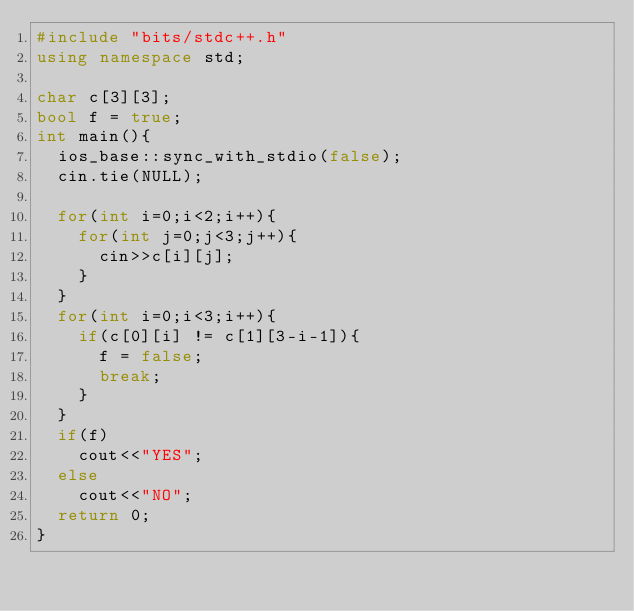Convert code to text. <code><loc_0><loc_0><loc_500><loc_500><_C++_>#include "bits/stdc++.h"
using namespace std;

char c[3][3];
bool f = true;
int main(){
	ios_base::sync_with_stdio(false);
	cin.tie(NULL);

	for(int i=0;i<2;i++){
		for(int j=0;j<3;j++){
			cin>>c[i][j];
		}
	}
	for(int i=0;i<3;i++){
		if(c[0][i] != c[1][3-i-1]){
			f = false;
			break;
		}
	}
	if(f)
		cout<<"YES";
	else
		cout<<"NO";
	return 0;
}</code> 